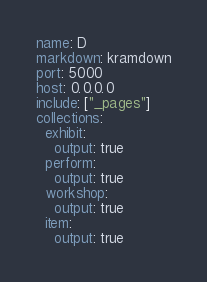Convert code to text. <code><loc_0><loc_0><loc_500><loc_500><_YAML_>name: D
markdown: kramdown
port: 5000
host: 0.0.0.0
include: ["_pages"]
collections:
  exhibit:
    output: true
  perform:
    output: true
  workshop:
    output: true
  item:
    output: true
</code> 